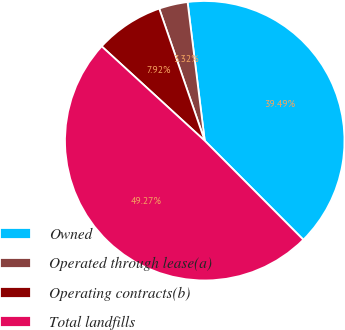Convert chart. <chart><loc_0><loc_0><loc_500><loc_500><pie_chart><fcel>Owned<fcel>Operated through lease(a)<fcel>Operating contracts(b)<fcel>Total landfills<nl><fcel>39.49%<fcel>3.32%<fcel>7.92%<fcel>49.27%<nl></chart> 